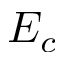<formula> <loc_0><loc_0><loc_500><loc_500>E _ { c }</formula> 